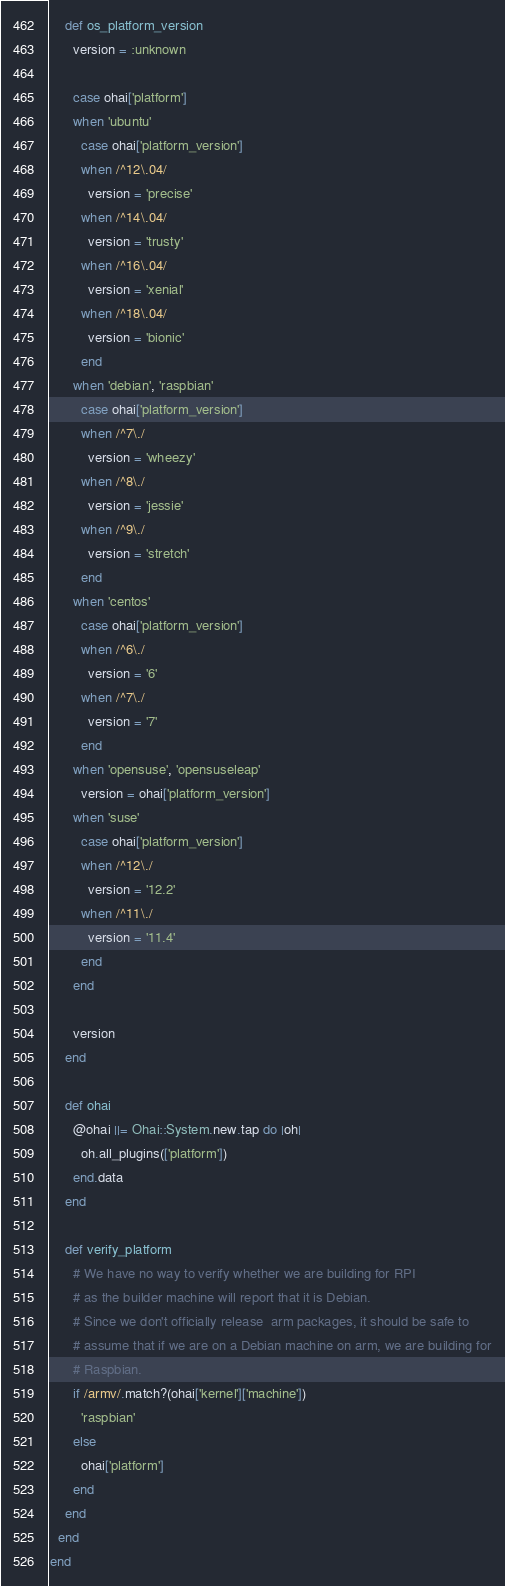<code> <loc_0><loc_0><loc_500><loc_500><_Ruby_>
    def os_platform_version
      version = :unknown

      case ohai['platform']
      when 'ubuntu'
        case ohai['platform_version']
        when /^12\.04/
          version = 'precise'
        when /^14\.04/
          version = 'trusty'
        when /^16\.04/
          version = 'xenial'
        when /^18\.04/
          version = 'bionic'
        end
      when 'debian', 'raspbian'
        case ohai['platform_version']
        when /^7\./
          version = 'wheezy'
        when /^8\./
          version = 'jessie'
        when /^9\./
          version = 'stretch'
        end
      when 'centos'
        case ohai['platform_version']
        when /^6\./
          version = '6'
        when /^7\./
          version = '7'
        end
      when 'opensuse', 'opensuseleap'
        version = ohai['platform_version']
      when 'suse'
        case ohai['platform_version']
        when /^12\./
          version = '12.2'
        when /^11\./
          version = '11.4'
        end
      end

      version
    end

    def ohai
      @ohai ||= Ohai::System.new.tap do |oh|
        oh.all_plugins(['platform'])
      end.data
    end

    def verify_platform
      # We have no way to verify whether we are building for RPI
      # as the builder machine will report that it is Debian.
      # Since we don't officially release  arm packages, it should be safe to
      # assume that if we are on a Debian machine on arm, we are building for
      # Raspbian.
      if /armv/.match?(ohai['kernel']['machine'])
        'raspbian'
      else
        ohai['platform']
      end
    end
  end
end
</code> 